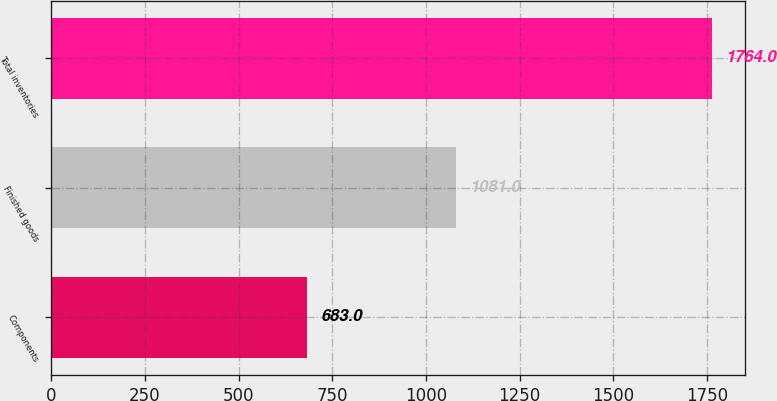<chart> <loc_0><loc_0><loc_500><loc_500><bar_chart><fcel>Components<fcel>Finished goods<fcel>Total inventories<nl><fcel>683<fcel>1081<fcel>1764<nl></chart> 